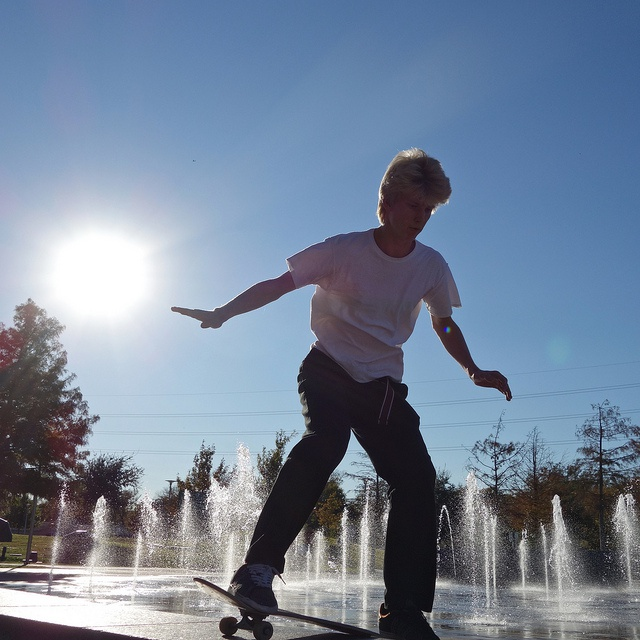Describe the objects in this image and their specific colors. I can see people in gray, black, purple, and lightblue tones and skateboard in gray, black, darkgray, and lightgray tones in this image. 